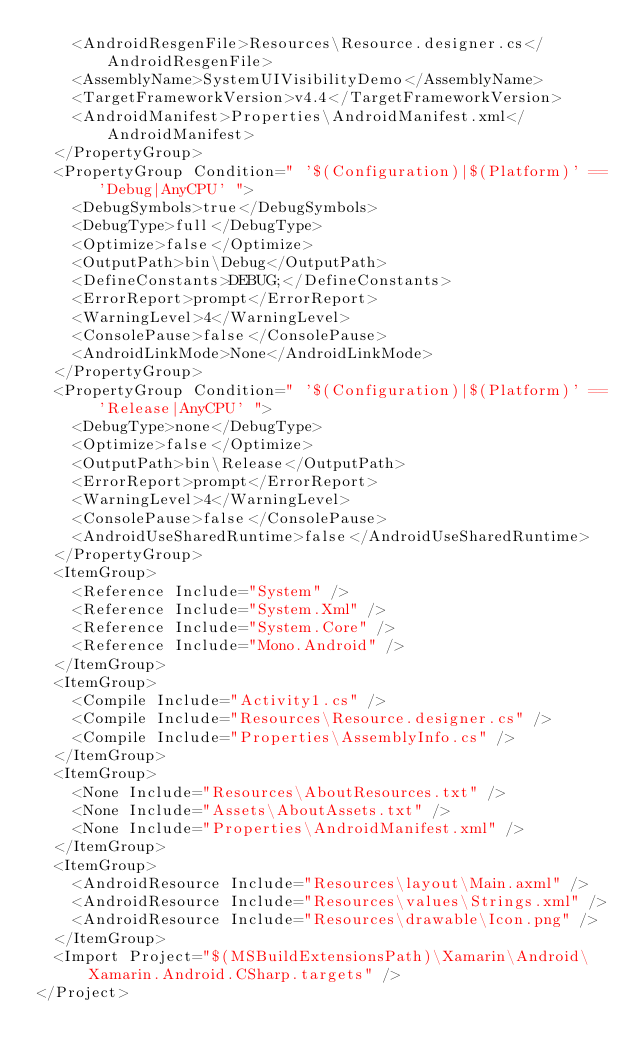<code> <loc_0><loc_0><loc_500><loc_500><_XML_>    <AndroidResgenFile>Resources\Resource.designer.cs</AndroidResgenFile>
    <AssemblyName>SystemUIVisibilityDemo</AssemblyName>
    <TargetFrameworkVersion>v4.4</TargetFrameworkVersion>
    <AndroidManifest>Properties\AndroidManifest.xml</AndroidManifest>
  </PropertyGroup>
  <PropertyGroup Condition=" '$(Configuration)|$(Platform)' == 'Debug|AnyCPU' ">
    <DebugSymbols>true</DebugSymbols>
    <DebugType>full</DebugType>
    <Optimize>false</Optimize>
    <OutputPath>bin\Debug</OutputPath>
    <DefineConstants>DEBUG;</DefineConstants>
    <ErrorReport>prompt</ErrorReport>
    <WarningLevel>4</WarningLevel>
    <ConsolePause>false</ConsolePause>
    <AndroidLinkMode>None</AndroidLinkMode>
  </PropertyGroup>
  <PropertyGroup Condition=" '$(Configuration)|$(Platform)' == 'Release|AnyCPU' ">
    <DebugType>none</DebugType>
    <Optimize>false</Optimize>
    <OutputPath>bin\Release</OutputPath>
    <ErrorReport>prompt</ErrorReport>
    <WarningLevel>4</WarningLevel>
    <ConsolePause>false</ConsolePause>
    <AndroidUseSharedRuntime>false</AndroidUseSharedRuntime>
  </PropertyGroup>
  <ItemGroup>
    <Reference Include="System" />
    <Reference Include="System.Xml" />
    <Reference Include="System.Core" />
    <Reference Include="Mono.Android" />
  </ItemGroup>
  <ItemGroup>
    <Compile Include="Activity1.cs" />
    <Compile Include="Resources\Resource.designer.cs" />
    <Compile Include="Properties\AssemblyInfo.cs" />
  </ItemGroup>
  <ItemGroup>
    <None Include="Resources\AboutResources.txt" />
    <None Include="Assets\AboutAssets.txt" />
    <None Include="Properties\AndroidManifest.xml" />
  </ItemGroup>
  <ItemGroup>
    <AndroidResource Include="Resources\layout\Main.axml" />
    <AndroidResource Include="Resources\values\Strings.xml" />
    <AndroidResource Include="Resources\drawable\Icon.png" />
  </ItemGroup>
  <Import Project="$(MSBuildExtensionsPath)\Xamarin\Android\Xamarin.Android.CSharp.targets" />
</Project></code> 